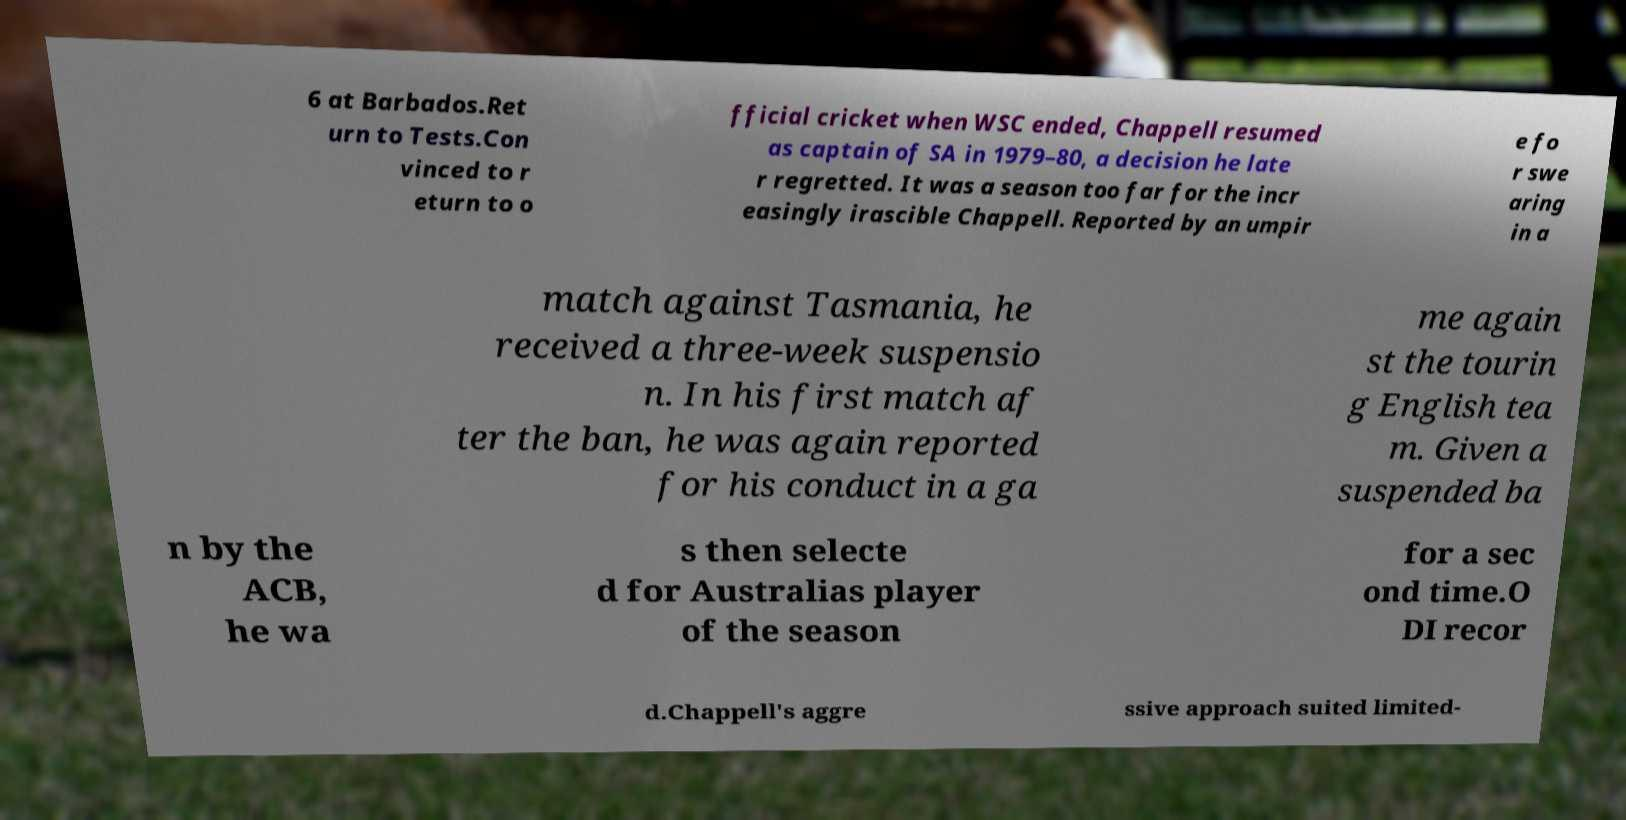What messages or text are displayed in this image? I need them in a readable, typed format. 6 at Barbados.Ret urn to Tests.Con vinced to r eturn to o fficial cricket when WSC ended, Chappell resumed as captain of SA in 1979–80, a decision he late r regretted. It was a season too far for the incr easingly irascible Chappell. Reported by an umpir e fo r swe aring in a match against Tasmania, he received a three-week suspensio n. In his first match af ter the ban, he was again reported for his conduct in a ga me again st the tourin g English tea m. Given a suspended ba n by the ACB, he wa s then selecte d for Australias player of the season for a sec ond time.O DI recor d.Chappell's aggre ssive approach suited limited- 